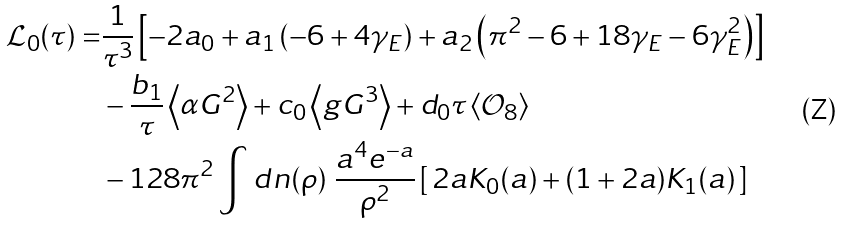Convert formula to latex. <formula><loc_0><loc_0><loc_500><loc_500>\mathcal { L } _ { 0 } ( \tau ) = & \frac { 1 } { \tau ^ { 3 } } \left [ - 2 a _ { 0 } + a _ { 1 } \left ( - 6 + 4 \gamma _ { E } \right ) + a _ { 2 } \left ( \pi ^ { 2 } - 6 + 1 8 \gamma _ { E } - 6 \gamma _ { E } ^ { 2 } \right ) \right ] \\ & - \frac { b _ { 1 } } { \tau } \left \langle \alpha G ^ { 2 } \right \rangle + c _ { 0 } \left \langle g G ^ { 3 } \right \rangle + d _ { 0 } \tau \left \langle \mathcal { O } _ { 8 } \right \rangle \\ & - 1 2 8 \pi ^ { 2 } \int d n ( \rho ) \ \frac { a ^ { 4 } e ^ { - a } } { \rho ^ { 2 } } \left [ \, 2 a K _ { 0 } ( a ) + ( 1 + 2 a ) K _ { 1 } ( a ) \, \right ]</formula> 